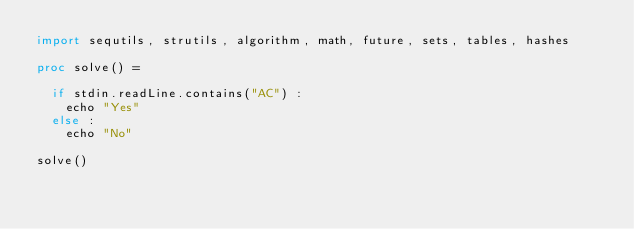Convert code to text. <code><loc_0><loc_0><loc_500><loc_500><_Nim_>import sequtils, strutils, algorithm, math, future, sets, tables, hashes

proc solve() =

  if stdin.readLine.contains("AC") : 
    echo "Yes"
  else : 
    echo "No"

solve()</code> 